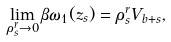Convert formula to latex. <formula><loc_0><loc_0><loc_500><loc_500>\lim _ { \rho _ { s } ^ { r } \to 0 } \beta \omega _ { 1 } ( z _ { s } ) = \rho _ { s } ^ { r } V _ { b + s } ,</formula> 